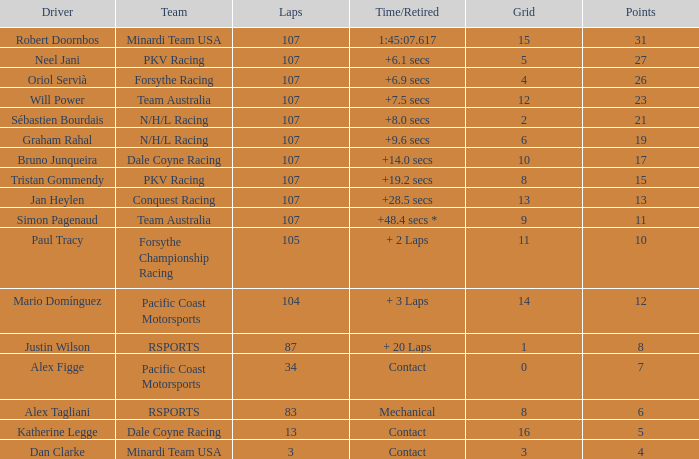What is mario domínguez's average Grid? 14.0. 